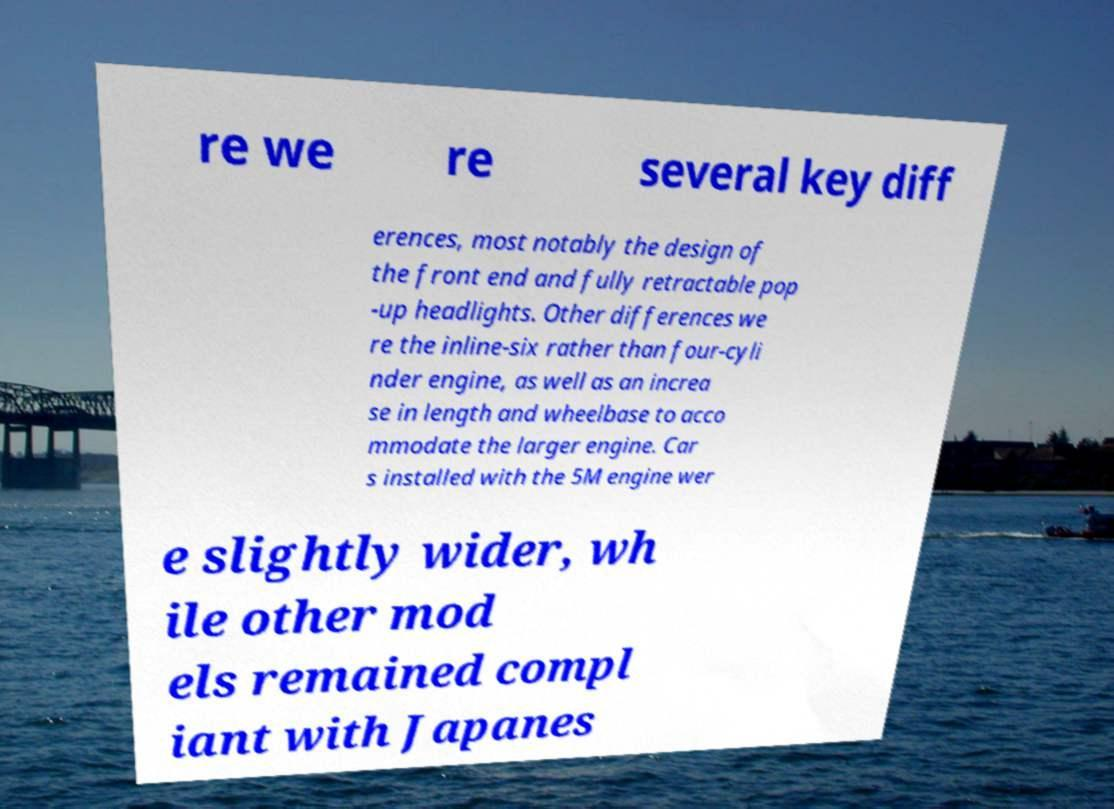What messages or text are displayed in this image? I need them in a readable, typed format. re we re several key diff erences, most notably the design of the front end and fully retractable pop -up headlights. Other differences we re the inline-six rather than four-cyli nder engine, as well as an increa se in length and wheelbase to acco mmodate the larger engine. Car s installed with the 5M engine wer e slightly wider, wh ile other mod els remained compl iant with Japanes 